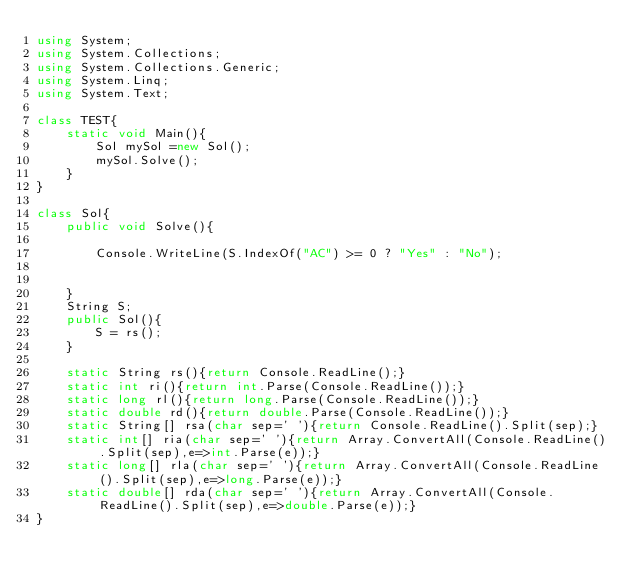Convert code to text. <code><loc_0><loc_0><loc_500><loc_500><_C#_>using System;
using System.Collections;
using System.Collections.Generic;
using System.Linq;
using System.Text;

class TEST{
	static void Main(){
		Sol mySol =new Sol();
		mySol.Solve();
	}
}

class Sol{
	public void Solve(){
		
		Console.WriteLine(S.IndexOf("AC") >= 0 ? "Yes" : "No");
		
		
	}
	String S;
	public Sol(){
		S = rs();
	}

	static String rs(){return Console.ReadLine();}
	static int ri(){return int.Parse(Console.ReadLine());}
	static long rl(){return long.Parse(Console.ReadLine());}
	static double rd(){return double.Parse(Console.ReadLine());}
	static String[] rsa(char sep=' '){return Console.ReadLine().Split(sep);}
	static int[] ria(char sep=' '){return Array.ConvertAll(Console.ReadLine().Split(sep),e=>int.Parse(e));}
	static long[] rla(char sep=' '){return Array.ConvertAll(Console.ReadLine().Split(sep),e=>long.Parse(e));}
	static double[] rda(char sep=' '){return Array.ConvertAll(Console.ReadLine().Split(sep),e=>double.Parse(e));}
}
</code> 